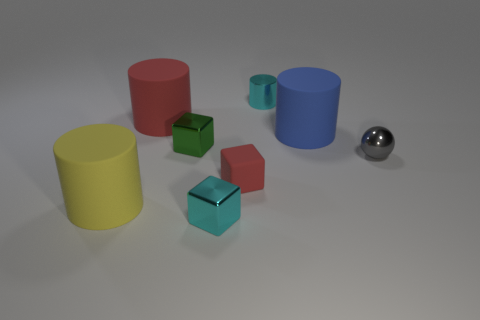The cyan thing behind the tiny cyan metal object in front of the big yellow object is what shape?
Your answer should be very brief. Cylinder. How many other objects are the same color as the metallic cylinder?
Your answer should be very brief. 1. Do the tiny cyan thing that is in front of the gray object and the small cyan object behind the yellow rubber object have the same material?
Your response must be concise. Yes. There is a red matte thing left of the red matte block; how big is it?
Offer a very short reply. Large. What material is the cyan object that is the same shape as the large yellow rubber thing?
Give a very brief answer. Metal. There is a matte object to the right of the cyan cylinder; what is its shape?
Provide a succinct answer. Cylinder. What number of matte things have the same shape as the tiny gray shiny thing?
Ensure brevity in your answer.  0. Are there the same number of tiny cyan cubes that are on the left side of the big red cylinder and red blocks that are in front of the small red block?
Your response must be concise. Yes. Are there any red balls that have the same material as the large blue cylinder?
Make the answer very short. No. Does the big yellow thing have the same material as the small cyan cylinder?
Your response must be concise. No. 